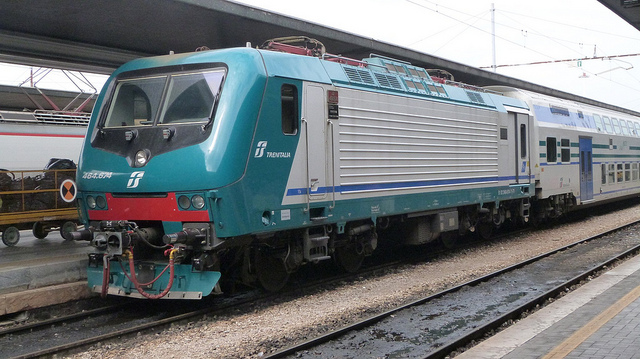<image>Which railroad owns these? It is unknown which railroad owns these. It could be 'Amtrak', 'Tadtalla', or 'Train Guys'. Which railroad owns these? I don't know which railroad owns these. It can be owned by 'train guys', 'tadtalla', 'trans', 'amtrak', 'usa' or others. 